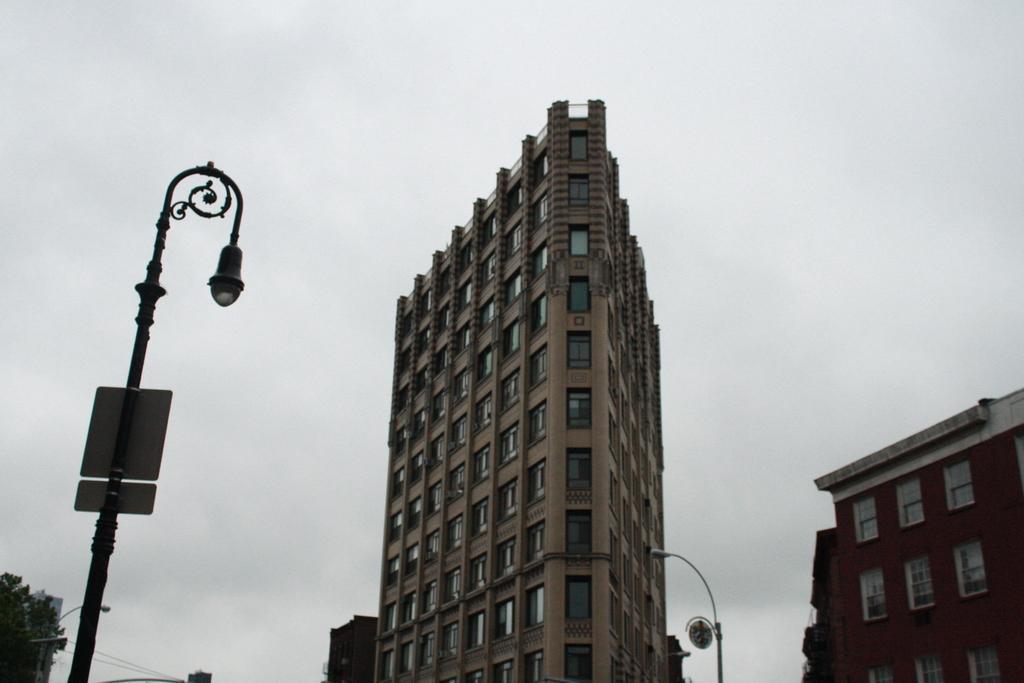What type of structures can be seen in the image? There are buildings in the image. What else is present in the image besides buildings? There are poles and a tree on the left side of the image. What is visible at the top of the image? The sky is visible at the top of the image. What type of trade is being conducted in the image? There is no indication of any trade being conducted in the image. Can you tell me what the father is doing in the image? There is no person, let alone a father, present in the image. 